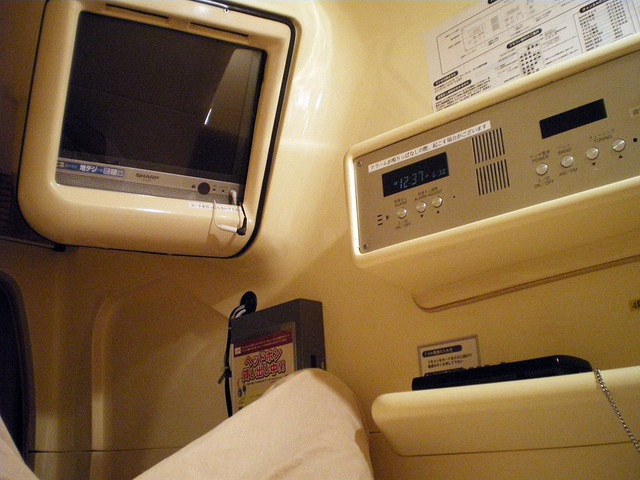Describe the objects in this image and their specific colors. I can see tv in black, gray, and maroon tones and remote in black, maroon, and olive tones in this image. 